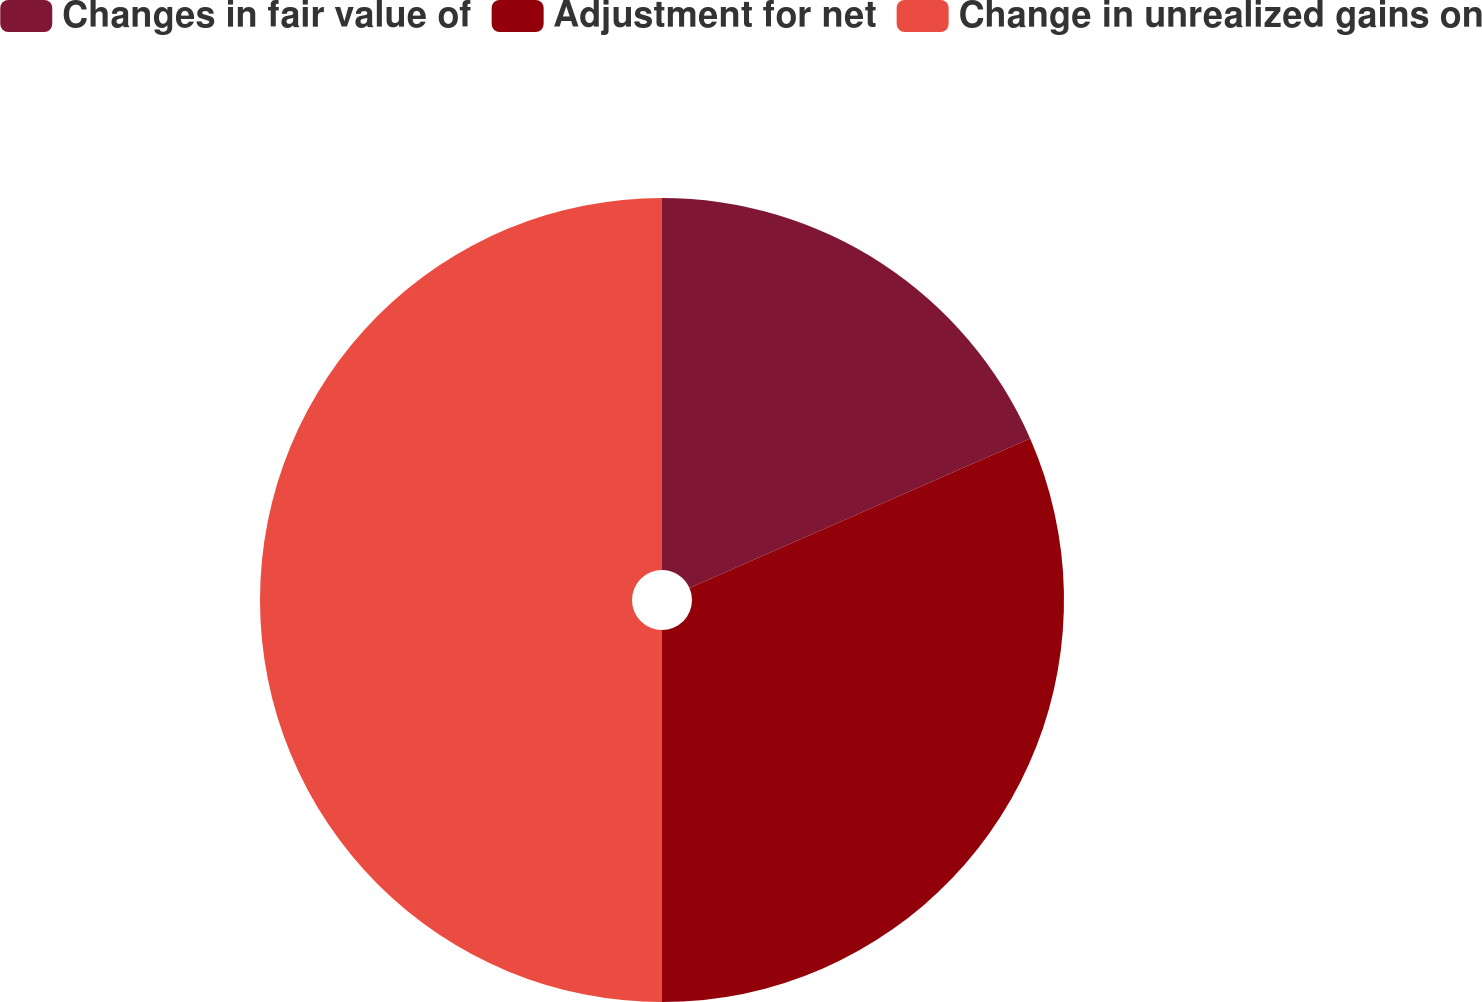Convert chart to OTSL. <chart><loc_0><loc_0><loc_500><loc_500><pie_chart><fcel>Changes in fair value of<fcel>Adjustment for net<fcel>Change in unrealized gains on<nl><fcel>18.42%<fcel>31.58%<fcel>50.0%<nl></chart> 